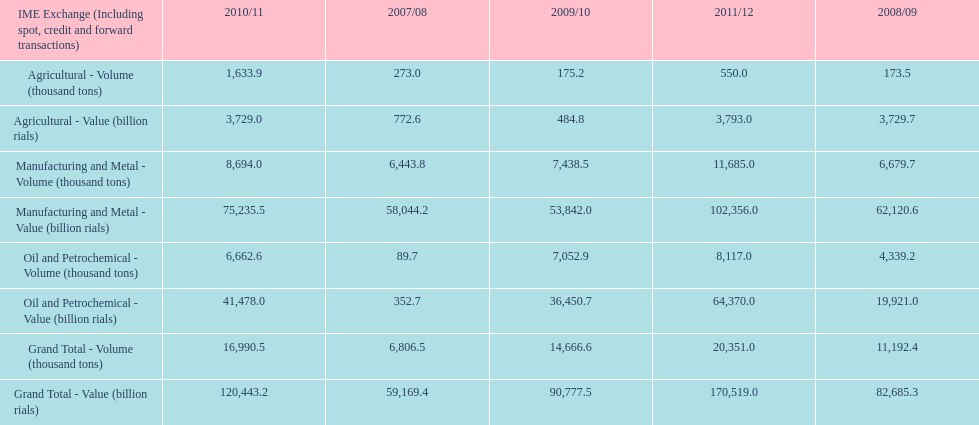How many consecutive year did the grand total value grow in iran? 4. 